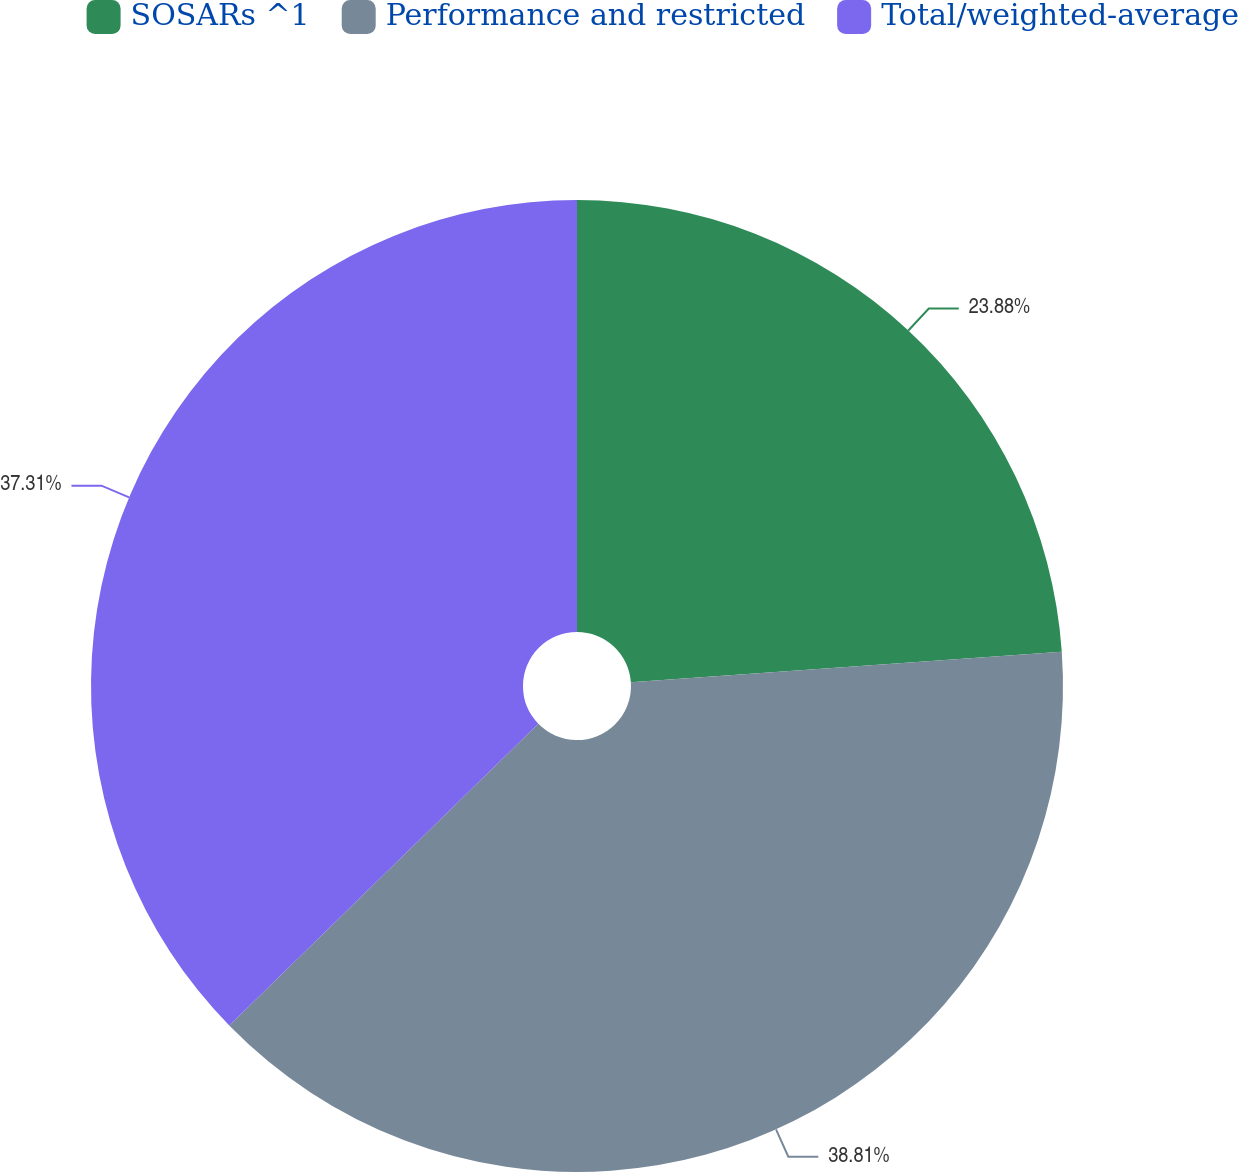Convert chart. <chart><loc_0><loc_0><loc_500><loc_500><pie_chart><fcel>SOSARs ^1<fcel>Performance and restricted<fcel>Total/weighted-average<nl><fcel>23.88%<fcel>38.81%<fcel>37.31%<nl></chart> 